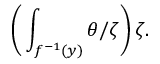<formula> <loc_0><loc_0><loc_500><loc_500>{ \left ( } \int _ { f ^ { - 1 } ( y ) } \theta / \zeta { \right ) } \, \zeta .</formula> 